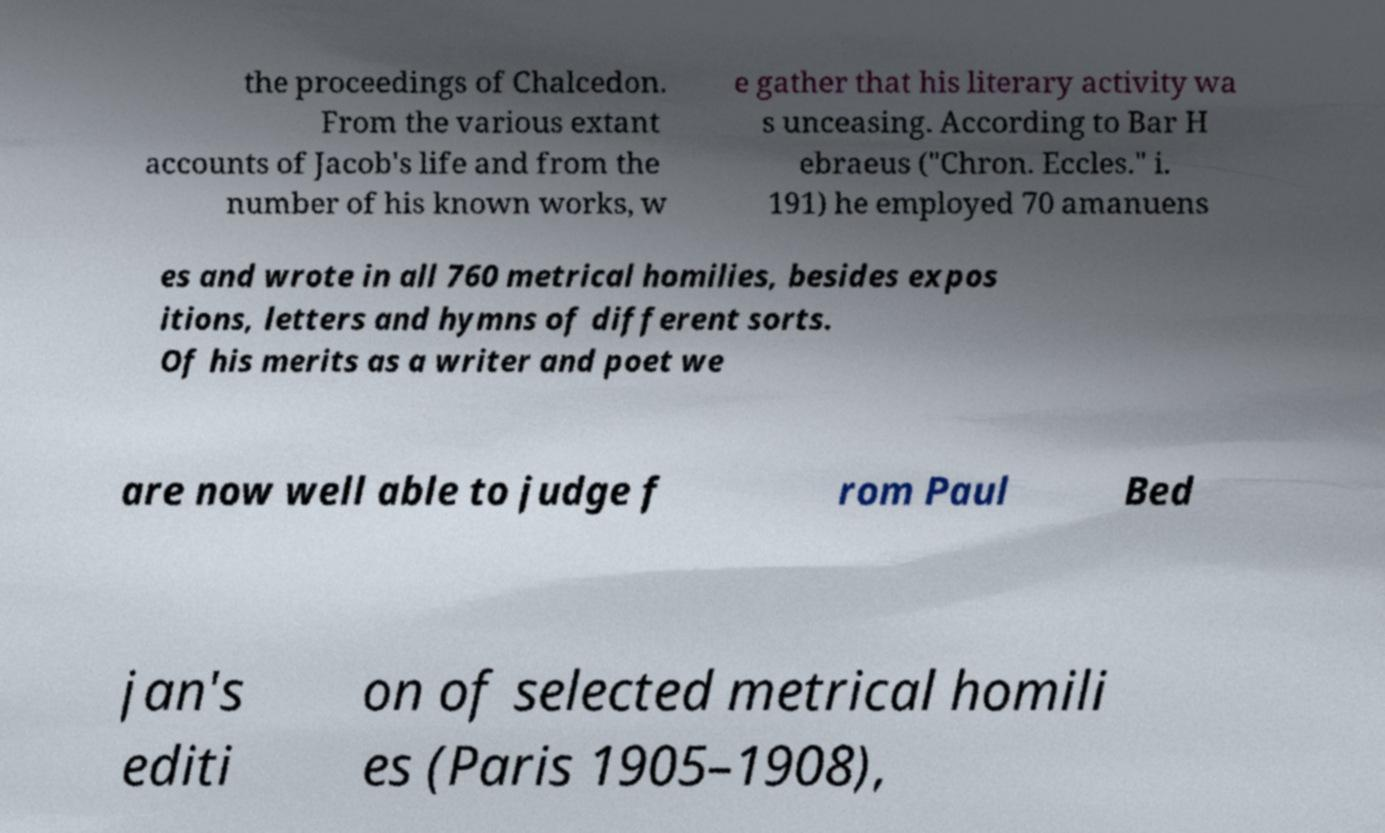What messages or text are displayed in this image? I need them in a readable, typed format. the proceedings of Chalcedon. From the various extant accounts of Jacob's life and from the number of his known works, w e gather that his literary activity wa s unceasing. According to Bar H ebraeus ("Chron. Eccles." i. 191) he employed 70 amanuens es and wrote in all 760 metrical homilies, besides expos itions, letters and hymns of different sorts. Of his merits as a writer and poet we are now well able to judge f rom Paul Bed jan's editi on of selected metrical homili es (Paris 1905–1908), 